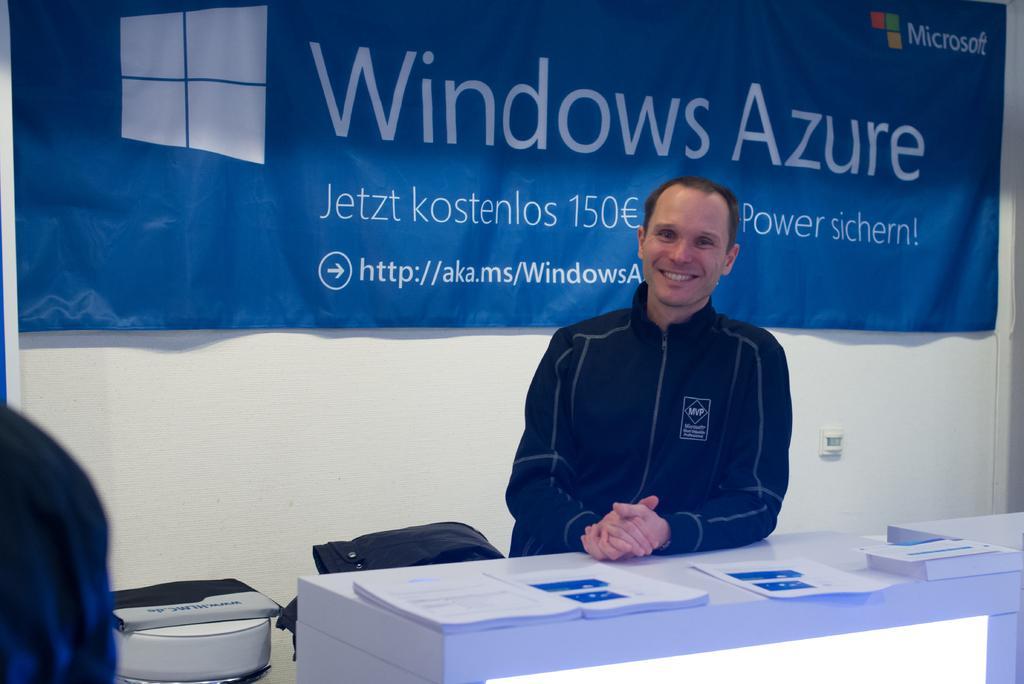Who is present in the image? There is a person in the image. What is the person's facial expression? The person is smiling. What is on the table in the image? There are papers on a table. What can be seen in the background of the image? There are objects visible in the background. What color is the banner in the background? There is a blue color banner in the background. What type of operation is the person performing on the papers in the image? There is no indication in the image that the person is performing an operation on the papers. 